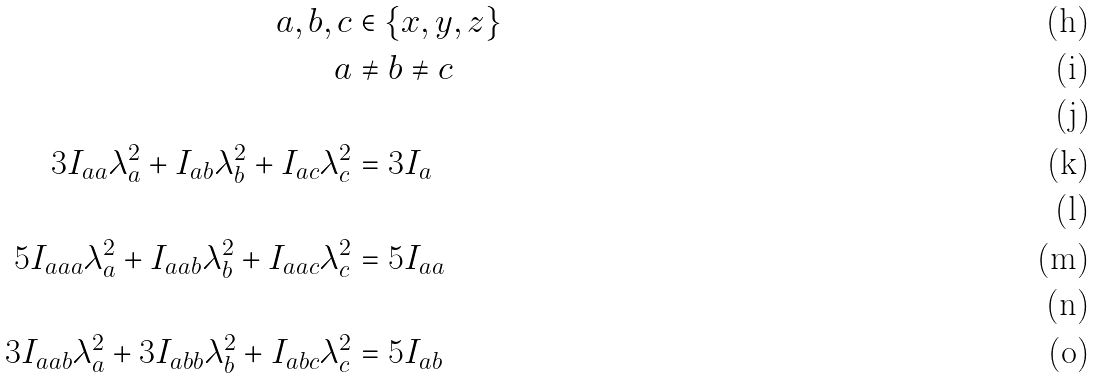<formula> <loc_0><loc_0><loc_500><loc_500>a , b , c & \in \left \{ x , y , z \right \} \\ a & \neq b \neq c \\ & \\ 3 I _ { a a } \lambda _ { a } ^ { 2 } + I _ { a b } \lambda _ { b } ^ { 2 } + I _ { a c } \lambda _ { c } ^ { 2 } & = 3 I _ { a } \\ & \\ 5 I _ { a a a } \lambda _ { a } ^ { 2 } + I _ { a a b } \lambda _ { b } ^ { 2 } + I _ { a a c } \lambda _ { c } ^ { 2 } & = 5 I _ { a a } \\ & \\ 3 I _ { a a b } \lambda _ { a } ^ { 2 } + 3 I _ { a b b } \lambda _ { b } ^ { 2 } + I _ { a b c } \lambda _ { c } ^ { 2 } & = 5 I _ { a b }</formula> 